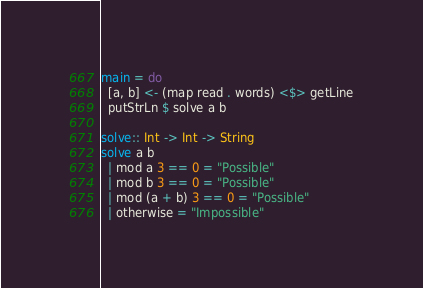Convert code to text. <code><loc_0><loc_0><loc_500><loc_500><_Haskell_>main = do
  [a, b] <- (map read . words) <$> getLine
  putStrLn $ solve a b

solve:: Int -> Int -> String
solve a b
  | mod a 3 == 0 = "Possible"
  | mod b 3 == 0 = "Possible"
  | mod (a + b) 3 == 0 = "Possible"
  | otherwise = "Impossible"</code> 